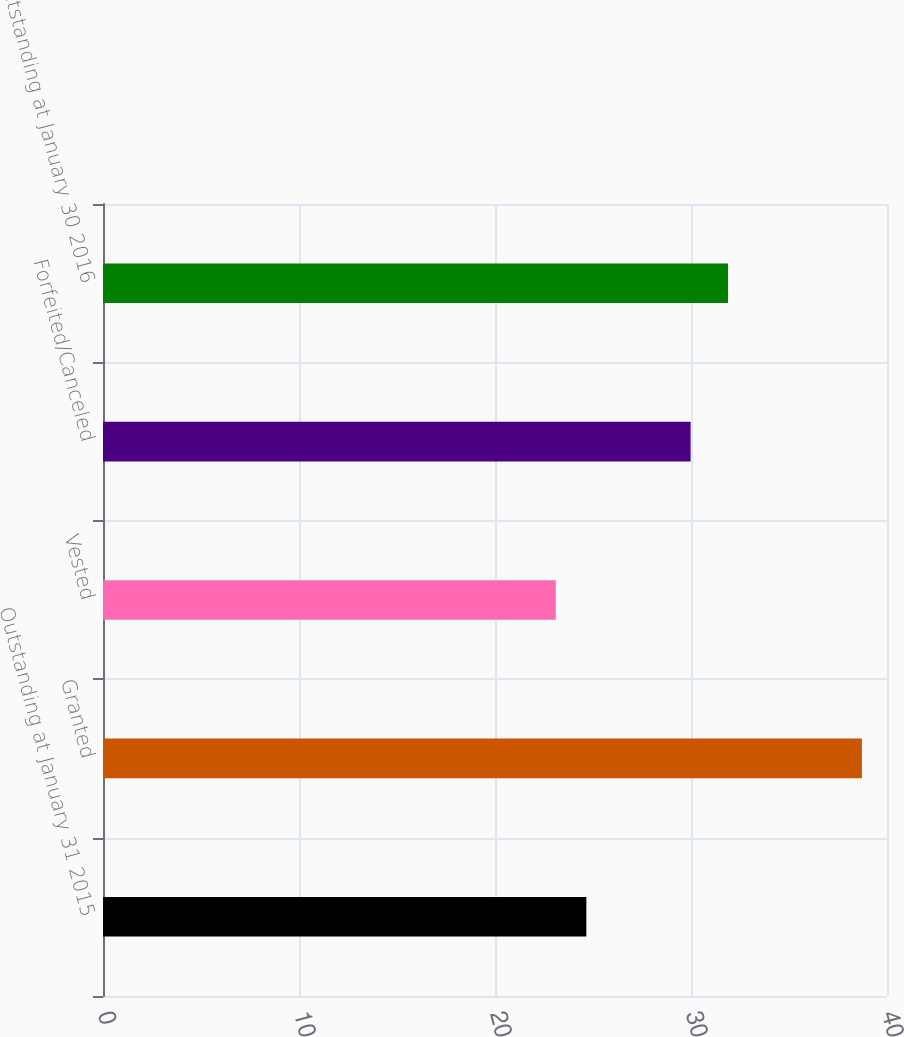Convert chart. <chart><loc_0><loc_0><loc_500><loc_500><bar_chart><fcel>Outstanding at January 31 2015<fcel>Granted<fcel>Vested<fcel>Forfeited/Canceled<fcel>Outstanding at January 30 2016<nl><fcel>24.66<fcel>38.72<fcel>23.1<fcel>29.98<fcel>31.89<nl></chart> 